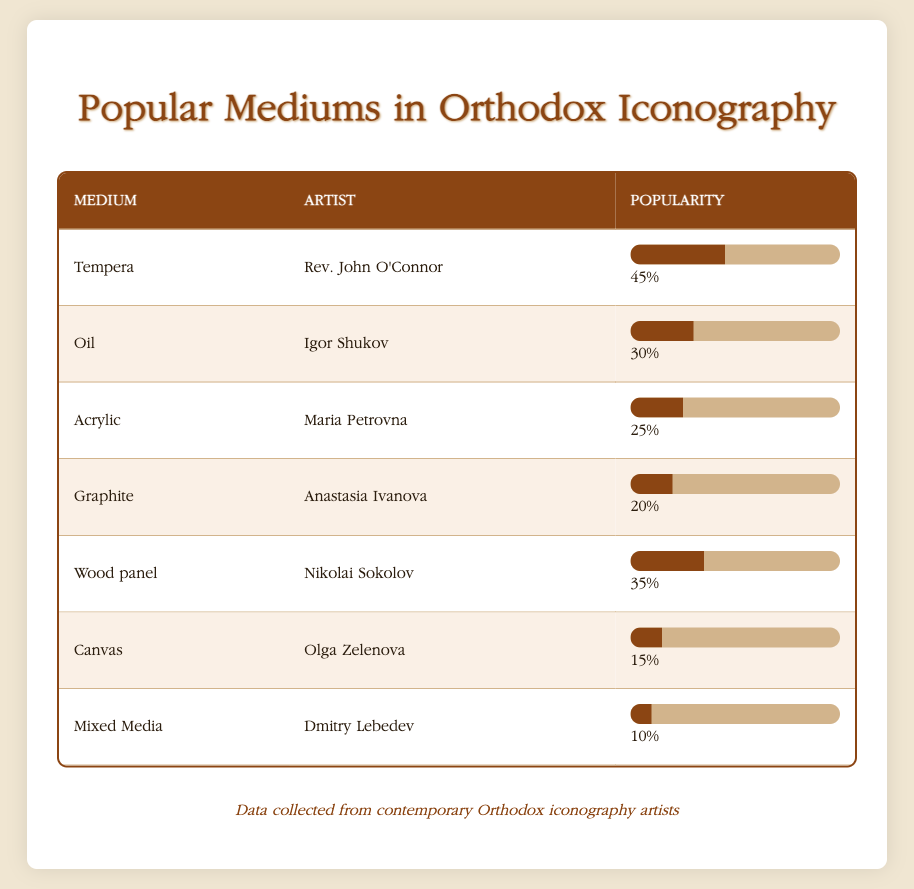What is the most popular medium used in Orthodox iconography according to the table? The table lists various mediums and their popularity percentages. The highest percentage is associated with Tempera at 45%.
Answer: Tempera Which artist is associated with the medium of Oil? The table shows that Igor Shukov is the artist linked with the medium of Oil.
Answer: Igor Shukov What is the average popularity percentage of the mediums listed in the table? To find the average, sum all the popularity values: 45 + 30 + 25 + 20 + 35 + 15 + 10 = 180. Since there are 7 mediums, the average popularity is 180 / 7 ≈ 25.71.
Answer: 25.71 Is Mixed Media the least popular medium according to the data? By reviewing the popularity values in the table, Mixed Media has a value of 10, which is lower than all other mediums listed. Thus, it is indeed the least popular.
Answer: Yes How many mediums have a popularity percentage greater than 20? To determine this, we count the entries with popularity above 20: Tempera (45), Oil (30), Acrylic (25), and Wood panel (35). There are four entries that meet this criterion.
Answer: 4 What is the difference in popularity between the mediums of Tempera and Graphite? We take the popularity percent of Tempera (45) and subtract the popularity percent of Graphite (20): 45 - 20 = 25. So, the difference is 25.
Answer: 25 Which two mediums together have a total popularity percentage greater than 70? Investigating pairs of mediums, we find that Tempera (45) and Wood panel (35) together equal 80 (45 + 35), which exceeds 70. Therefore, these two mediums satisfy the condition.
Answer: Tempera and Wood panel Does the table indicate that Canvas is more popular than Mixed Media? By comparing the popularity percentages, Canvas has a popularity of 15, while Mixed Media has 10, which confirms that Canvas is indeed more popular.
Answer: Yes 